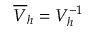<formula> <loc_0><loc_0><loc_500><loc_500>\overline { V } _ { h } = V _ { h } ^ { - 1 }</formula> 